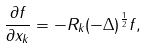<formula> <loc_0><loc_0><loc_500><loc_500>\frac { \partial f } { \partial x _ { k } } = - R _ { k } ( - \Delta ) ^ { \frac { 1 } { 2 } } f ,</formula> 